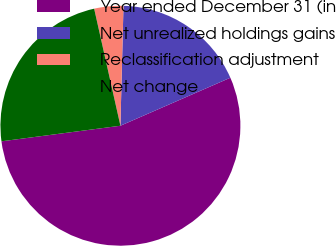<chart> <loc_0><loc_0><loc_500><loc_500><pie_chart><fcel>Year ended December 31 (in<fcel>Net unrealized holdings gains<fcel>Reclassification adjustment<fcel>Net change<nl><fcel>54.48%<fcel>18.04%<fcel>3.92%<fcel>23.56%<nl></chart> 